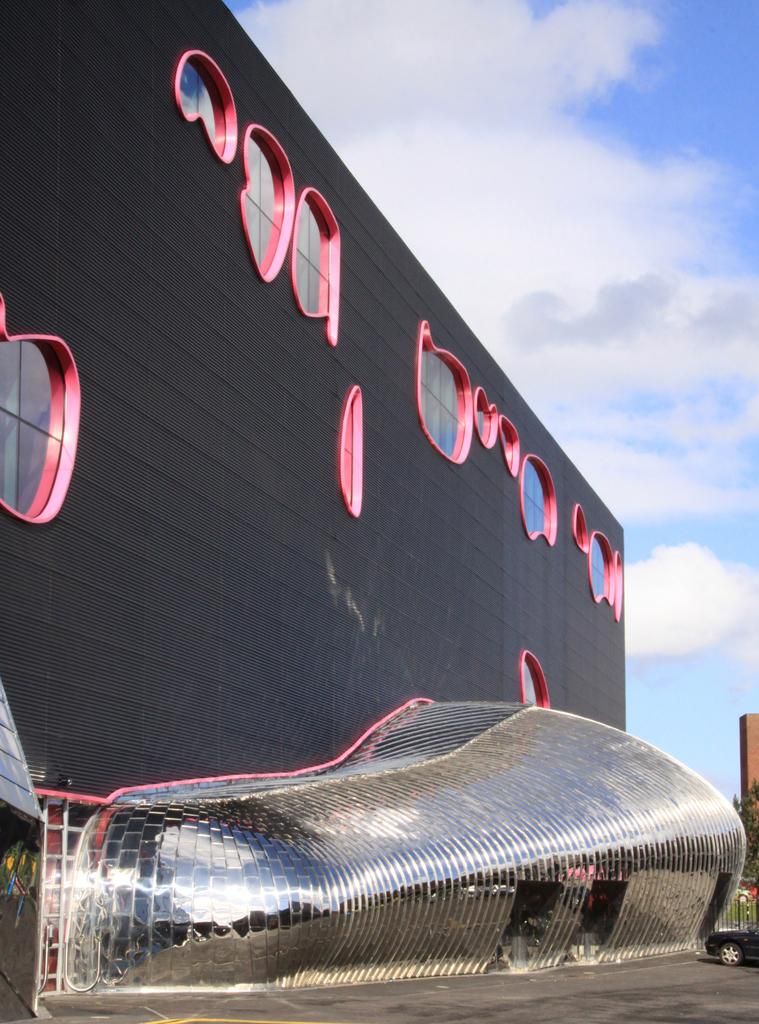What type of structure is visible in the image? There is a building with windows in the image. What is in front of the building? There is a fence and a vehicle present in front of the building. What can be seen in the background of the image? Trees and the sky are visible in the image. What is the condition of the sky in the image? Clouds are present in the sky. What type of yarn is being used to create the fence in the image? There is no yarn present in the image; the fence is made of a solid material. Can you see any gold objects in the image? There is no gold object present in the image. 